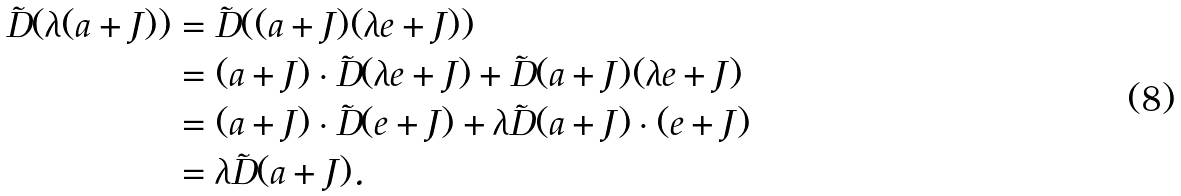Convert formula to latex. <formula><loc_0><loc_0><loc_500><loc_500>\tilde { D } ( \lambda ( a + J ) ) & = \tilde { D } ( ( a + J ) ( \lambda e + J ) ) \\ & = ( a + J ) \cdot \tilde { D } ( \lambda e + J ) + \tilde { D } ( a + J ) ( \lambda e + J ) \\ & = ( a + J ) \cdot \tilde { D } ( e + J ) + \lambda \tilde { D } ( a + J ) \cdot ( e + J ) \\ & = \lambda \tilde { D } ( a + J ) .</formula> 